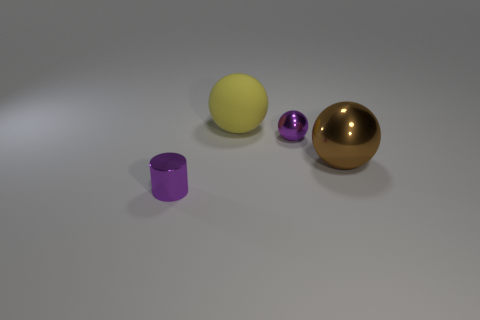Does the shiny sphere left of the big metal object have the same color as the metal cylinder?
Offer a very short reply. Yes. What material is the tiny cylinder that is the same color as the tiny ball?
Make the answer very short. Metal. What is the size of the metallic sphere that is the same color as the tiny cylinder?
Ensure brevity in your answer.  Small. Is there anything else that has the same material as the yellow sphere?
Offer a terse response. No. Is there any other thing that is the same color as the tiny metallic sphere?
Make the answer very short. Yes. What number of things are large brown shiny things or large objects right of the yellow ball?
Your answer should be very brief. 1. What color is the small shiny thing on the right side of the thing that is on the left side of the sphere behind the purple ball?
Offer a terse response. Purple. There is a tiny object that is the same shape as the big yellow thing; what is it made of?
Your answer should be very brief. Metal. The matte sphere is what color?
Give a very brief answer. Yellow. Do the rubber sphere and the shiny cylinder have the same color?
Offer a terse response. No. 